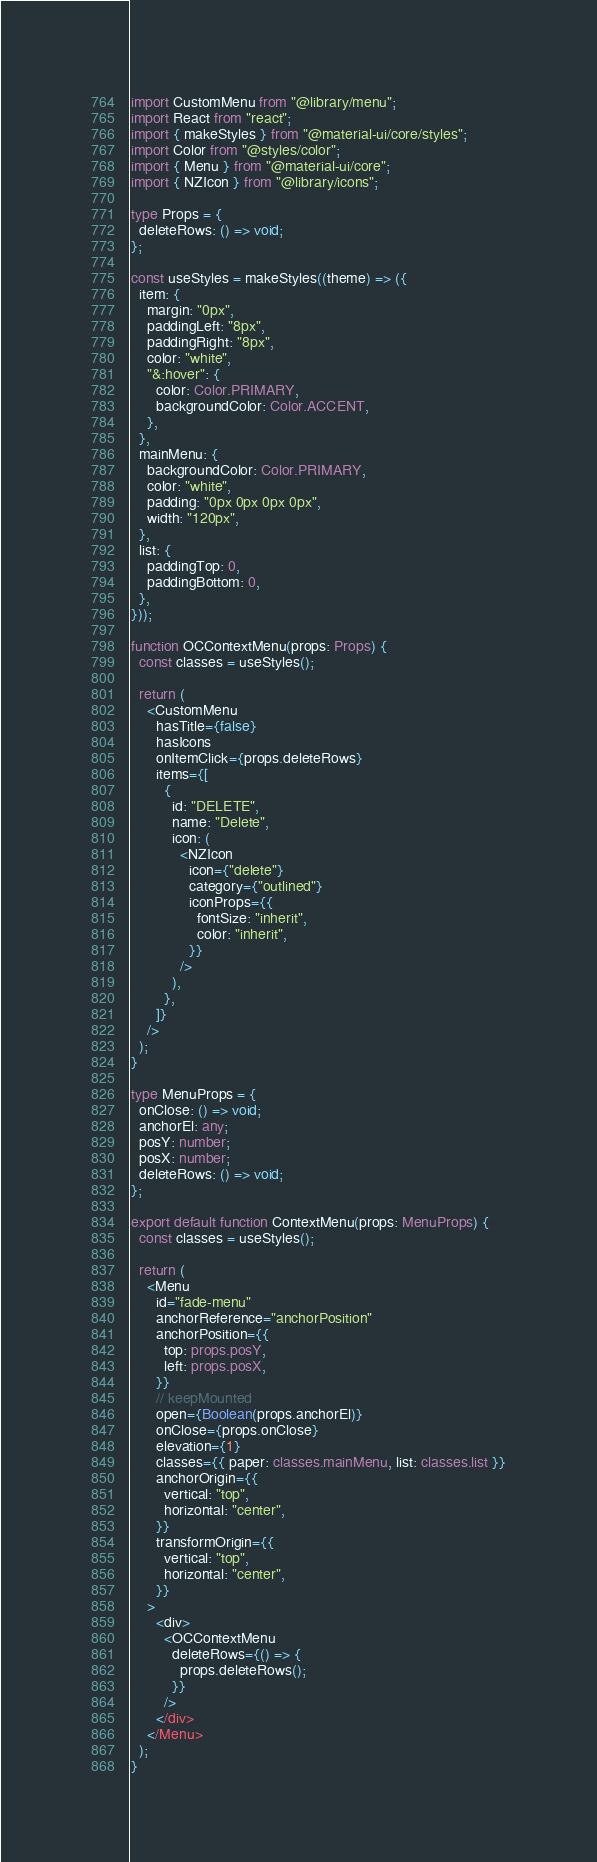Convert code to text. <code><loc_0><loc_0><loc_500><loc_500><_TypeScript_>import CustomMenu from "@library/menu";
import React from "react";
import { makeStyles } from "@material-ui/core/styles";
import Color from "@styles/color";
import { Menu } from "@material-ui/core";
import { NZIcon } from "@library/icons";

type Props = {
  deleteRows: () => void;
};

const useStyles = makeStyles((theme) => ({
  item: {
    margin: "0px",
    paddingLeft: "8px",
    paddingRight: "8px",
    color: "white",
    "&:hover": {
      color: Color.PRIMARY,
      backgroundColor: Color.ACCENT,
    },
  },
  mainMenu: {
    backgroundColor: Color.PRIMARY,
    color: "white",
    padding: "0px 0px 0px 0px",
    width: "120px",
  },
  list: {
    paddingTop: 0,
    paddingBottom: 0,
  },
}));

function OCContextMenu(props: Props) {
  const classes = useStyles();

  return (
    <CustomMenu
      hasTitle={false}
      hasIcons
      onItemClick={props.deleteRows}
      items={[
        {
          id: "DELETE",
          name: "Delete",
          icon: (
            <NZIcon
              icon={"delete"}
              category={"outlined"}
              iconProps={{
                fontSize: "inherit",
                color: "inherit",
              }}
            />
          ),
        },
      ]}
    />
  );
}

type MenuProps = {
  onClose: () => void;
  anchorEl: any;
  posY: number;
  posX: number;
  deleteRows: () => void;
};

export default function ContextMenu(props: MenuProps) {
  const classes = useStyles();

  return (
    <Menu
      id="fade-menu"
      anchorReference="anchorPosition"
      anchorPosition={{
        top: props.posY,
        left: props.posX,
      }}
      // keepMounted
      open={Boolean(props.anchorEl)}
      onClose={props.onClose}
      elevation={1}
      classes={{ paper: classes.mainMenu, list: classes.list }}
      anchorOrigin={{
        vertical: "top",
        horizontal: "center",
      }}
      transformOrigin={{
        vertical: "top",
        horizontal: "center",
      }}
    >
      <div>
        <OCContextMenu
          deleteRows={() => {
            props.deleteRows();
          }}
        />
      </div>
    </Menu>
  );
}
</code> 